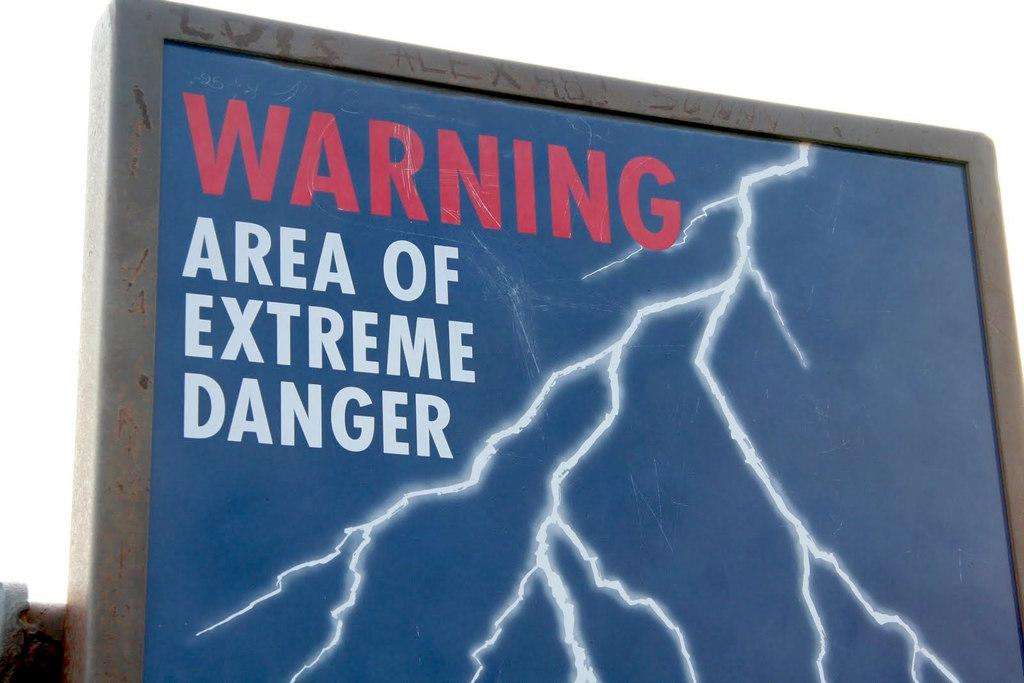<image>
Give a short and clear explanation of the subsequent image. a sign that says 'warning area of extreme danger' on it 